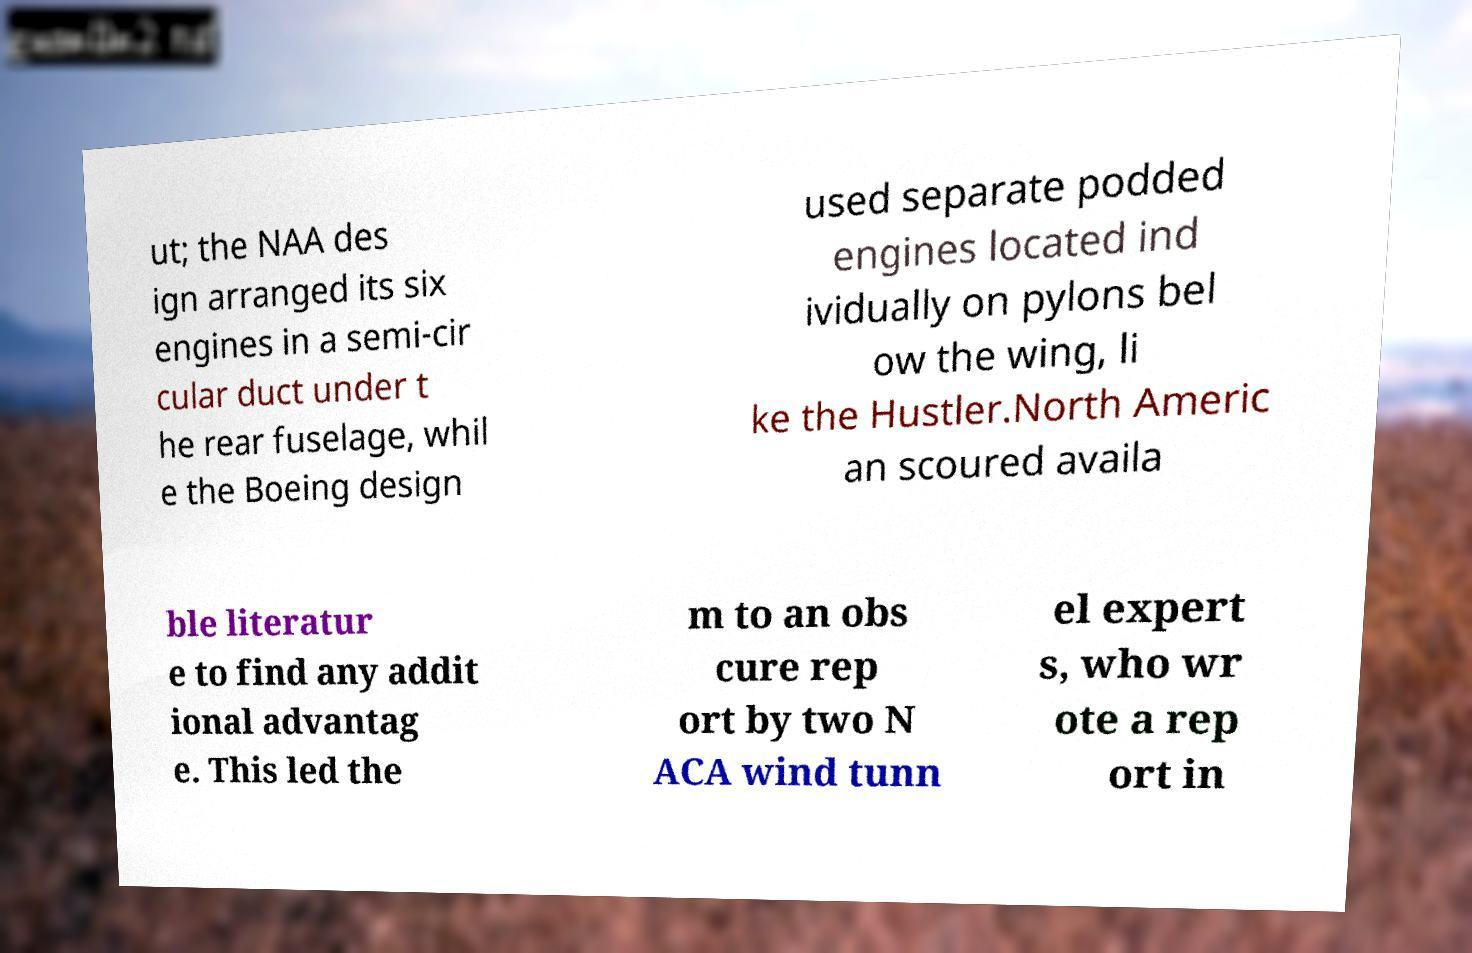Can you accurately transcribe the text from the provided image for me? ut; the NAA des ign arranged its six engines in a semi-cir cular duct under t he rear fuselage, whil e the Boeing design used separate podded engines located ind ividually on pylons bel ow the wing, li ke the Hustler.North Americ an scoured availa ble literatur e to find any addit ional advantag e. This led the m to an obs cure rep ort by two N ACA wind tunn el expert s, who wr ote a rep ort in 